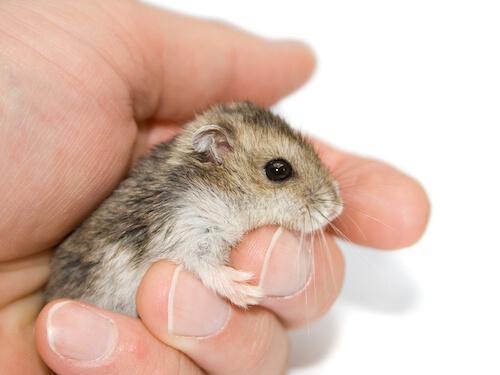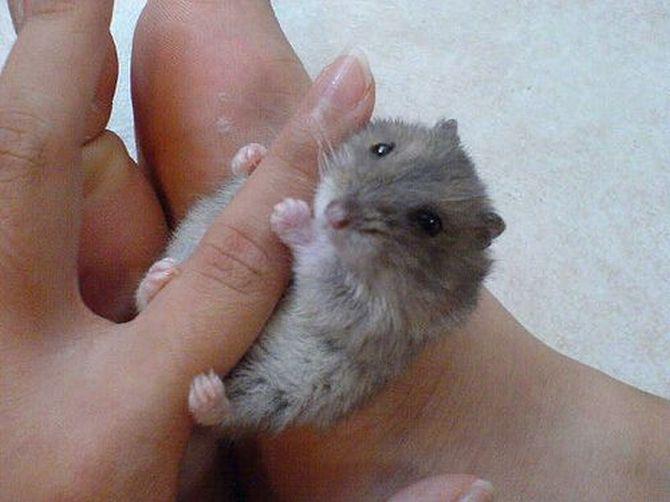The first image is the image on the left, the second image is the image on the right. Given the left and right images, does the statement "At least one image shows a small pet rodent posed with a larger pet animal on a white background." hold true? Answer yes or no. No. The first image is the image on the left, the second image is the image on the right. Given the left and right images, does the statement "The right image contains exactly two rodents." hold true? Answer yes or no. No. 